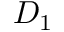<formula> <loc_0><loc_0><loc_500><loc_500>D _ { 1 }</formula> 